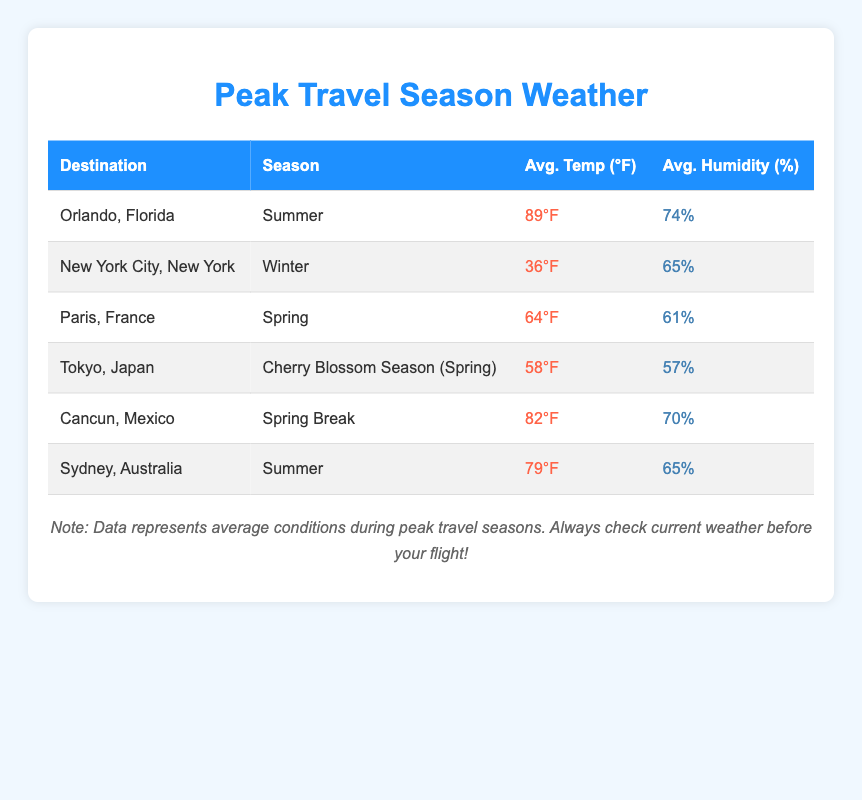What is the average temperature in Orlando, Florida during summer? According to the table, the average temperature in Orlando, Florida during summer is indicated as 89°F.
Answer: 89°F Which destination has the highest average humidity, and what is that percentage? By examining the table, Orlando, Florida has the highest average humidity at 74%.
Answer: Orlando, Florida, 74% Is Tokyo, Japan's average temperature during the cherry blossom season higher than Cancun, Mexico’s average temperature during spring break? The average temperature for Tokyo is 58°F, while Cancun has an average temperature of 82°F. Since 58 < 82, Tokyo's average is lower.
Answer: No What is the total average temperature of all destinations listed in the table? To calculate the total average temperature, we sum the following values: 89 + 36 + 64 + 58 + 82 + 79 = 408°F. Therefore, the total average temperature is 408°F.
Answer: 408°F Which season has the lowest average humidity percentage, and what is that percentage? From the table, the lowest average humidity percentage is found in Tokyo, Japan during the cherry blossom season at 57%.
Answer: Cherry Blossom Season, 57% Is the average temperature in spring break in Cancun higher than the average temperature in winter in New York City? The average temperature in Cancun during spring break is 82°F, while in New York City during winter it is 36°F. Since 82 > 36, the answer is yes.
Answer: Yes How many destinations are listed with an average temperature above 80°F? By looking at the table, the destinations with an average temperature above 80°F are Orlando (89°F) and Cancun (82°F). Therefore, there are two destinations.
Answer: 2 What is the average humidity percentage across all listed destinations? To find the average humidity, we first sum the humidity percentages: 74 + 65 + 61 + 57 + 70 + 65 = 392. Then, we divide by the number of destinations (6): 392 / 6 = 65.33%.
Answer: 65.33% 